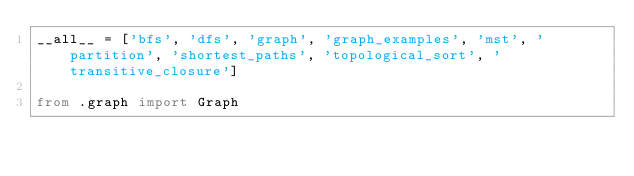<code> <loc_0><loc_0><loc_500><loc_500><_Python_>__all__ = ['bfs', 'dfs', 'graph', 'graph_examples', 'mst', 'partition', 'shortest_paths', 'topological_sort', 'transitive_closure']

from .graph import Graph</code> 